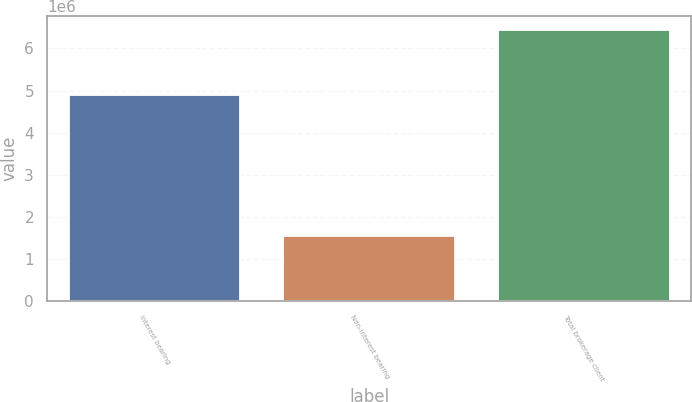<chart> <loc_0><loc_0><loc_500><loc_500><bar_chart><fcel>Interest bearing<fcel>Non-interest bearing<fcel>Total brokerage client<nl><fcel>4.89381e+06<fcel>1.55086e+06<fcel>6.44467e+06<nl></chart> 